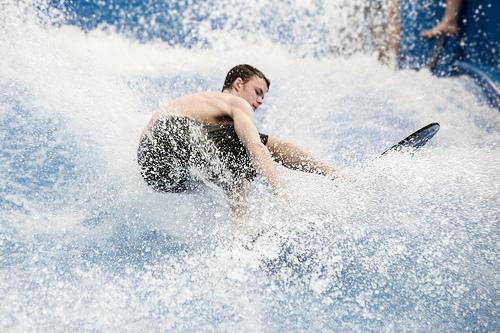How many feet are visible?
Give a very brief answer. 1. 